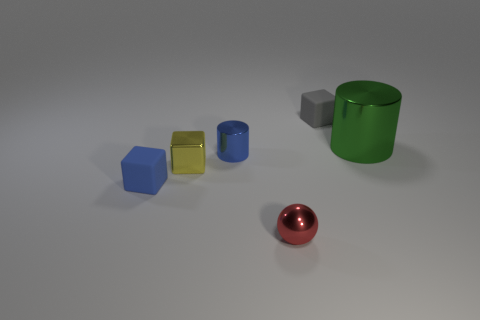Is the size of the blue rubber thing the same as the yellow block?
Your answer should be compact. Yes. What color is the small thing that is right of the tiny blue metallic object and to the left of the gray rubber block?
Ensure brevity in your answer.  Red. What is the size of the ball?
Give a very brief answer. Small. Does the metallic cylinder behind the small cylinder have the same color as the metal block?
Keep it short and to the point. No. Are there more small blue rubber objects on the left side of the tiny blue rubber cube than gray rubber things in front of the blue metallic cylinder?
Offer a terse response. No. Are there more small things than balls?
Offer a terse response. Yes. How big is the thing that is behind the small yellow metallic thing and in front of the big metal cylinder?
Provide a succinct answer. Small. What shape is the green metallic thing?
Offer a very short reply. Cylinder. Are there any other things that are the same size as the blue shiny cylinder?
Give a very brief answer. Yes. Is the number of tiny gray matte cubes left of the shiny block greater than the number of large yellow things?
Provide a succinct answer. No. 